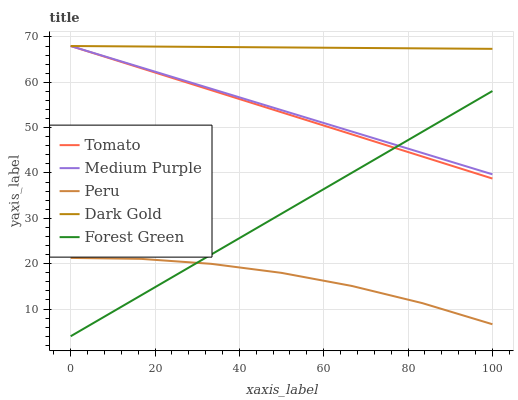Does Peru have the minimum area under the curve?
Answer yes or no. Yes. Does Dark Gold have the maximum area under the curve?
Answer yes or no. Yes. Does Medium Purple have the minimum area under the curve?
Answer yes or no. No. Does Medium Purple have the maximum area under the curve?
Answer yes or no. No. Is Dark Gold the smoothest?
Answer yes or no. Yes. Is Peru the roughest?
Answer yes or no. Yes. Is Medium Purple the smoothest?
Answer yes or no. No. Is Medium Purple the roughest?
Answer yes or no. No. Does Forest Green have the lowest value?
Answer yes or no. Yes. Does Medium Purple have the lowest value?
Answer yes or no. No. Does Dark Gold have the highest value?
Answer yes or no. Yes. Does Forest Green have the highest value?
Answer yes or no. No. Is Peru less than Dark Gold?
Answer yes or no. Yes. Is Tomato greater than Peru?
Answer yes or no. Yes. Does Medium Purple intersect Tomato?
Answer yes or no. Yes. Is Medium Purple less than Tomato?
Answer yes or no. No. Is Medium Purple greater than Tomato?
Answer yes or no. No. Does Peru intersect Dark Gold?
Answer yes or no. No. 